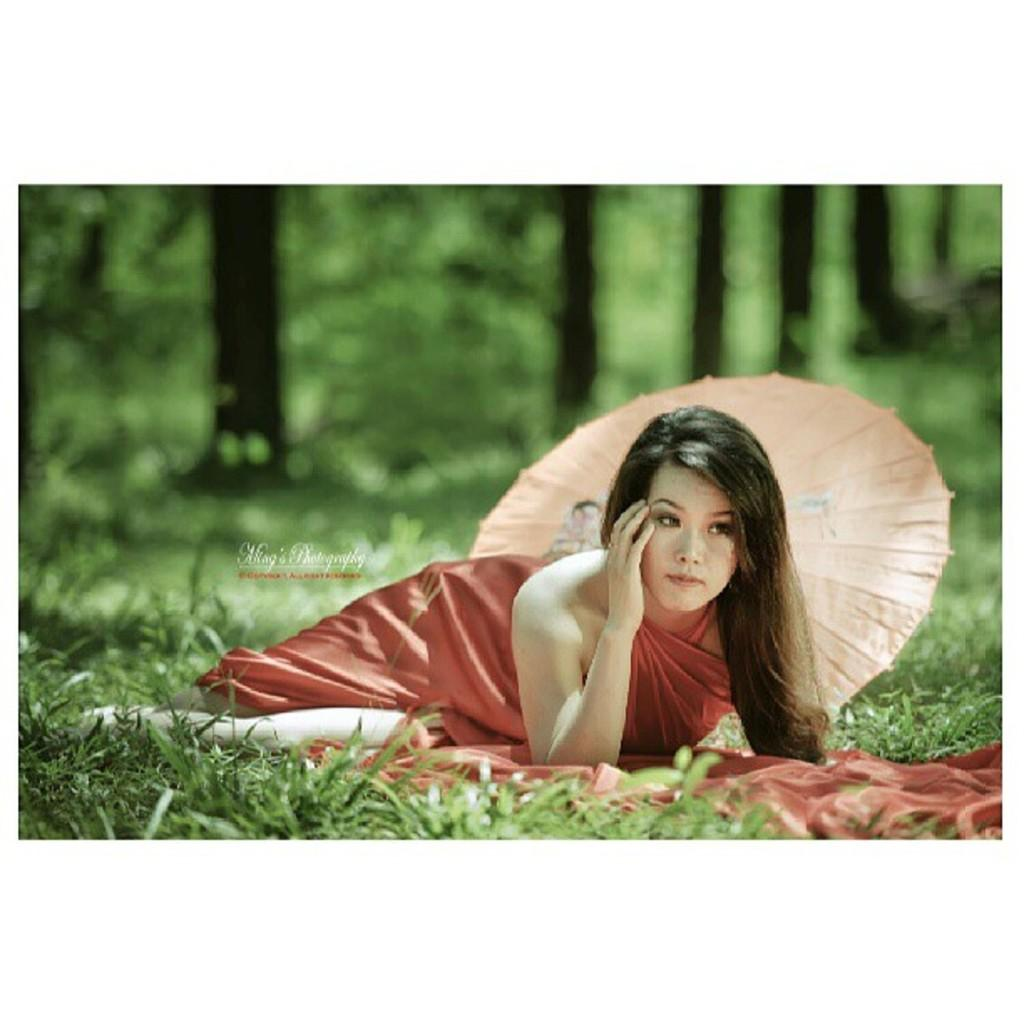What is the woman in the image doing? The woman is lying on the grass in the image. What object can be seen in the image that might provide shade? There is an umbrella in the image. What can be seen in the background of the image? Tree trunks are visible in the background of the image. Is there any indication of the image's origin or ownership? Yes, there is a watermark on the image. What type of patch is sewn onto the woman's clothing in the image? There is no patch visible on the woman's clothing in the image. What color is the sky in the image? The provided facts do not mention the color of the sky in the image. 